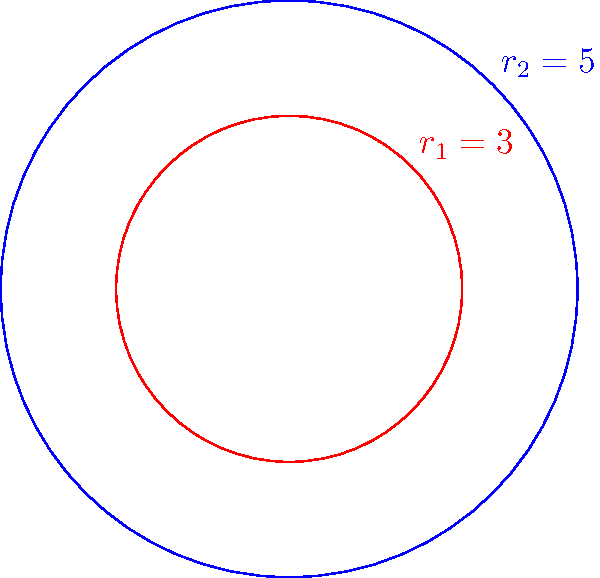In a Kubernetes cluster deployment diagram, two concentric circles represent different service boundaries. The inner circle has a radius of 3 units, while the outer circle has a radius of 5 units. Calculate the area of the region between these two circles, which represents the zone for deploying microservices. Round your answer to two decimal places. To find the area between two concentric circles, we need to:

1. Calculate the area of the larger circle (outer boundary)
2. Calculate the area of the smaller circle (inner boundary)
3. Subtract the smaller area from the larger area

Step 1: Area of the larger circle
$$A_2 = \pi r_2^2 = \pi (5)^2 = 25\pi$$

Step 2: Area of the smaller circle
$$A_1 = \pi r_1^2 = \pi (3)^2 = 9\pi$$

Step 3: Area between the circles
$$A = A_2 - A_1 = 25\pi - 9\pi = 16\pi$$

Converting to a decimal and rounding to two places:
$$16\pi \approx 50.27$$

This area represents the zone where microservices can be deployed in the Kubernetes cluster.
Answer: $50.27$ square units 